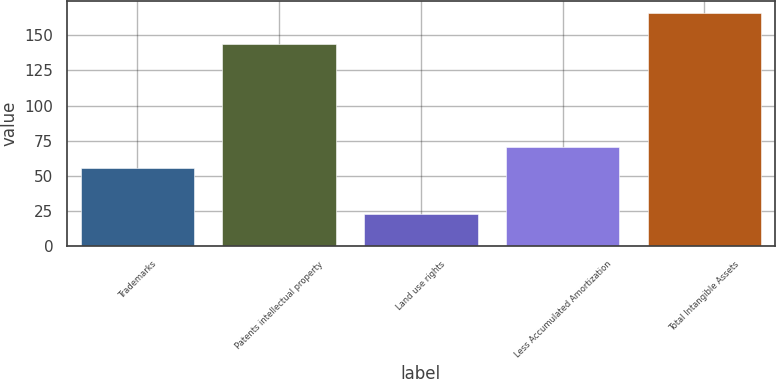<chart> <loc_0><loc_0><loc_500><loc_500><bar_chart><fcel>Trademarks<fcel>Patents intellectual property<fcel>Land use rights<fcel>Less Accumulated Amortization<fcel>Total Intangible Assets<nl><fcel>56<fcel>144<fcel>23<fcel>70.3<fcel>166<nl></chart> 